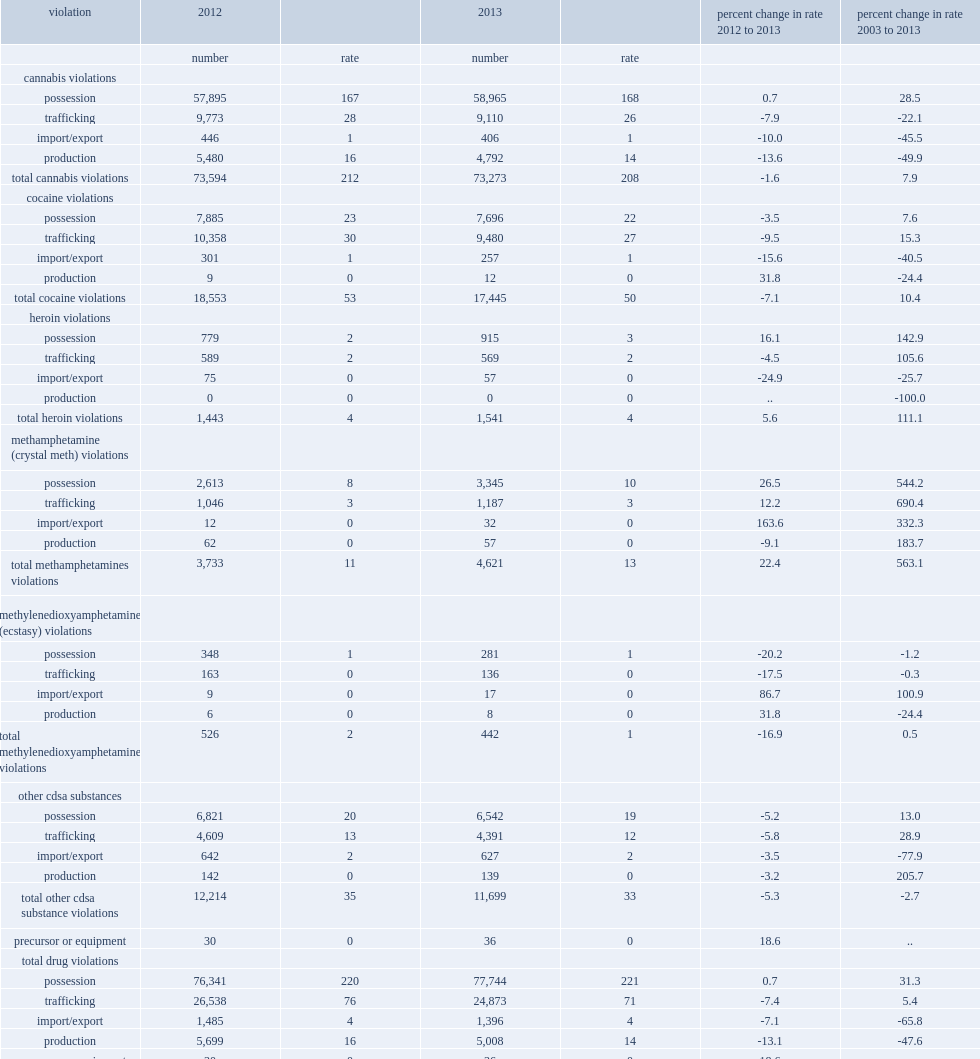How many cdsa violations police reported in 2013? 109057.0. What is the percentage of police-reported drug offences decreased in 2012? 2.1. How many violations did police-reported drug offences incresed per 100,000 population in 2013? 310.0. 